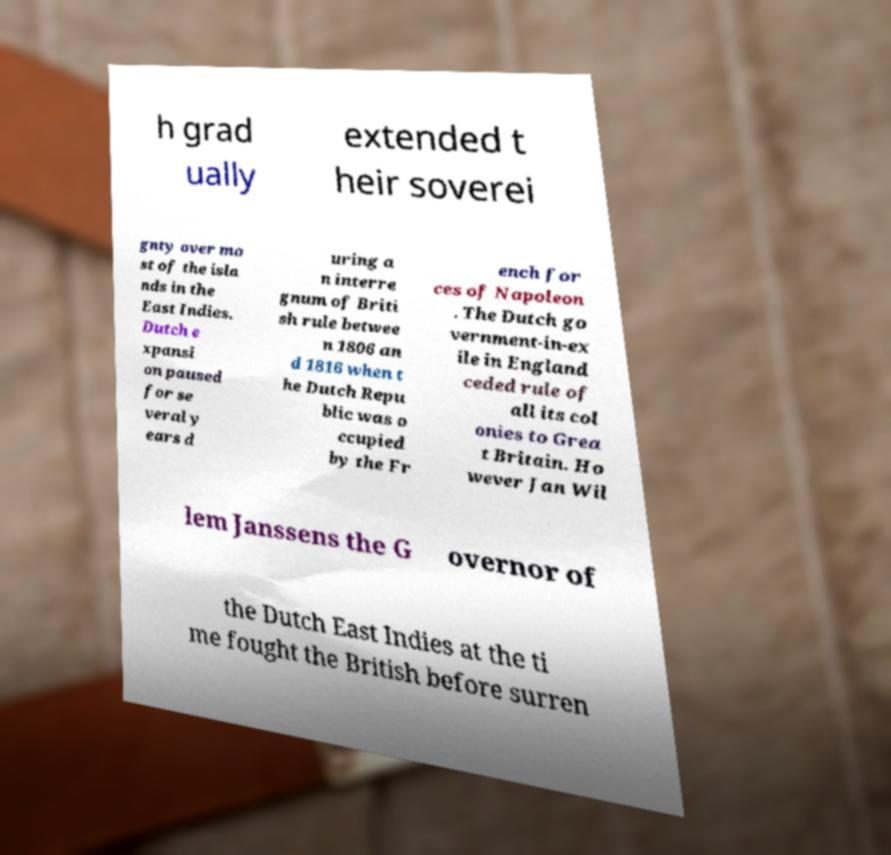For documentation purposes, I need the text within this image transcribed. Could you provide that? h grad ually extended t heir soverei gnty over mo st of the isla nds in the East Indies. Dutch e xpansi on paused for se veral y ears d uring a n interre gnum of Briti sh rule betwee n 1806 an d 1816 when t he Dutch Repu blic was o ccupied by the Fr ench for ces of Napoleon . The Dutch go vernment-in-ex ile in England ceded rule of all its col onies to Grea t Britain. Ho wever Jan Wil lem Janssens the G overnor of the Dutch East Indies at the ti me fought the British before surren 